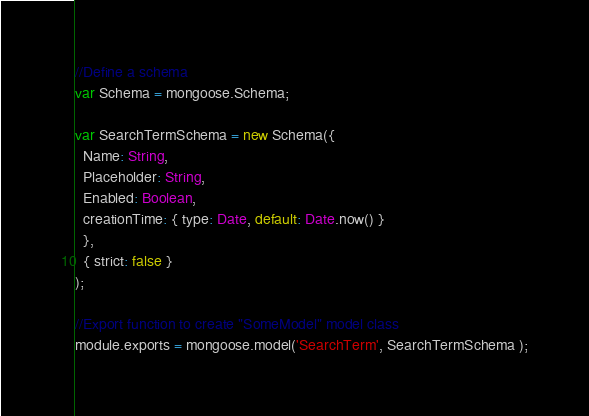Convert code to text. <code><loc_0><loc_0><loc_500><loc_500><_JavaScript_>
//Define a schema
var Schema = mongoose.Schema;

var SearchTermSchema = new Schema({
  Name: String,
  Placeholder: String,
  Enabled: Boolean,
  creationTime: { type: Date, default: Date.now() }
  },
  { strict: false }
);

//Export function to create "SomeModel" model class
module.exports = mongoose.model('SearchTerm', SearchTermSchema );</code> 